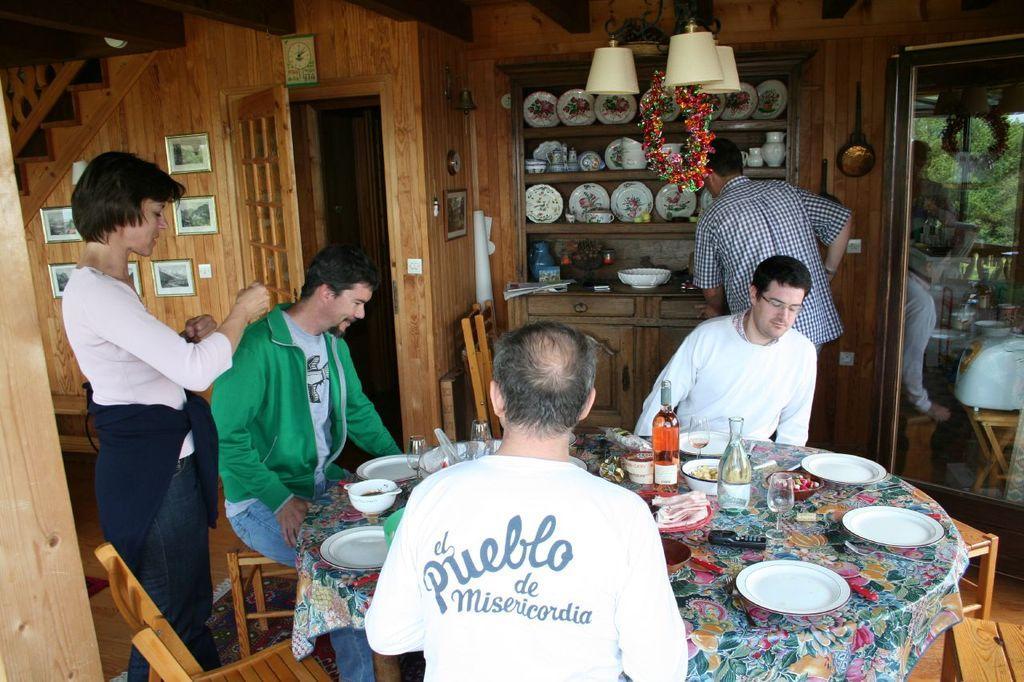How would you summarize this image in a sentence or two? In the picture we can see an inside view of a wooden house with some door, racks and some plates in it and a man standing near it and we can also see a dining table on it, we can see some food items and near it, we can see chairs and some men are sitting in it and to the wall we can see photo frames and we can also see a woman standing near the table. 